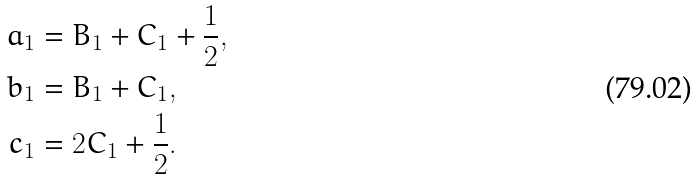Convert formula to latex. <formula><loc_0><loc_0><loc_500><loc_500>a _ { 1 } & = B _ { 1 } + C _ { 1 } + \frac { 1 } { 2 } , \\ b _ { 1 } & = B _ { 1 } + C _ { 1 } , \\ c _ { 1 } & = 2 C _ { 1 } + \frac { 1 } { 2 } .</formula> 